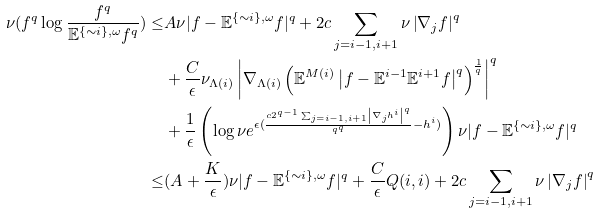Convert formula to latex. <formula><loc_0><loc_0><loc_500><loc_500>\nu ( f ^ { q } \log \frac { f ^ { q } } { \mathbb { E } ^ { \{ \sim i \} , \omega } f ^ { q } } ) \leq & A \nu | f - \mathbb { E } ^ { \{ \sim i \} , \omega } f | ^ { q } + 2 c \sum _ { j = i - 1 , i + 1 } \nu \left | \nabla _ { j } f \right | ^ { q } \\ & + \frac { C } { \epsilon } \nu _ { \Lambda ( i ) } \left | \nabla _ { \Lambda ( i ) } \left ( \mathbb { E } ^ { M ( i ) } \left | f - \mathbb { E } ^ { i - 1 } \mathbb { E } ^ { i + 1 } f \right | ^ { q } \right ) ^ { \frac { 1 } { q } } \right | ^ { q } \\ & + \frac { 1 } { \epsilon } \left ( \log \nu e ^ { \epsilon ( \frac { c 2 ^ { q - 1 } \sum _ { j = i - 1 , i + 1 } \left | \nabla _ { j } { h ^ { i } } \right | ^ { q } } { q ^ { q } } - { h ^ { i } } ) } \right ) \nu | f - \mathbb { E } ^ { \{ \sim i \} , \omega } f | ^ { q } \\ \leq & ( A + \frac { K } { \epsilon } ) \nu | f - \mathbb { E } ^ { \{ \sim i \} , \omega } f | ^ { q } + \frac { C } { \epsilon } Q ( i , i ) + 2 c \sum _ { j = i - 1 , i + 1 } \nu \left | \nabla _ { j } f \right | ^ { q }</formula> 